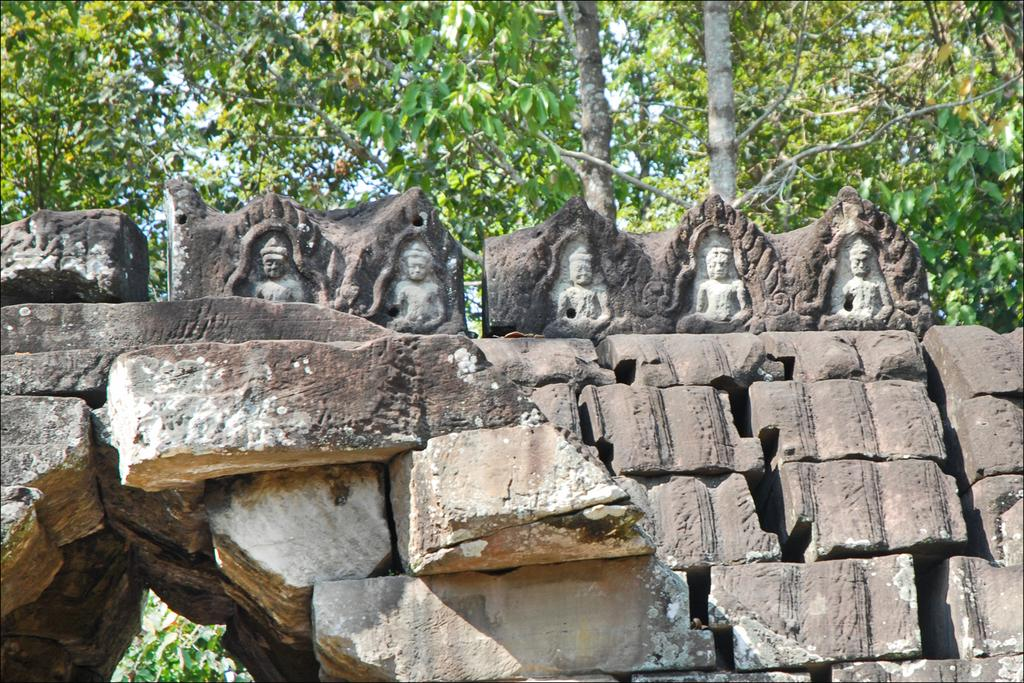What type of natural formation can be seen in the image? There are rocks in the image. What is placed on top of the rocks? There are statues on top of the rocks. What type of vegetation is visible behind the statues? There are trees behind the statues. What type of reaction can be seen in the blood bubbling around the rocks in the image? There is no blood or bubbling present in the image; it features rocks with statues on top and trees in the background. 